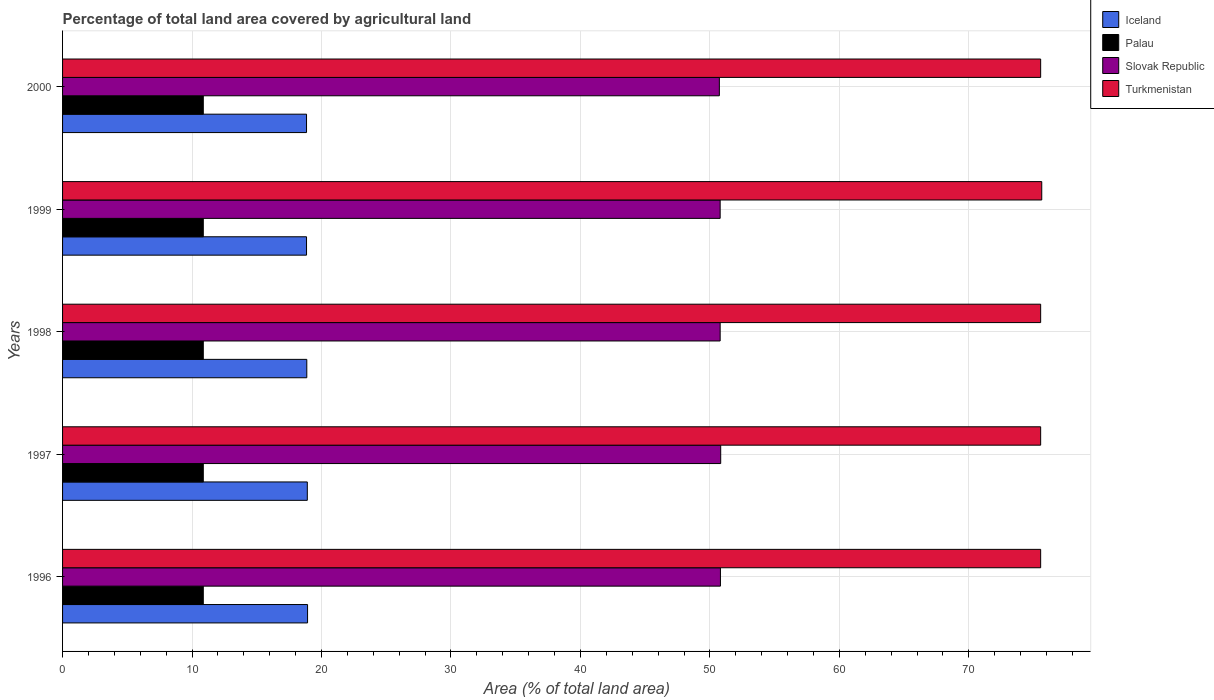How many different coloured bars are there?
Keep it short and to the point. 4. Are the number of bars per tick equal to the number of legend labels?
Your response must be concise. Yes. How many bars are there on the 1st tick from the top?
Provide a short and direct response. 4. What is the label of the 4th group of bars from the top?
Keep it short and to the point. 1997. What is the percentage of agricultural land in Iceland in 1999?
Offer a terse response. 18.84. Across all years, what is the maximum percentage of agricultural land in Turkmenistan?
Offer a terse response. 75.63. Across all years, what is the minimum percentage of agricultural land in Iceland?
Provide a succinct answer. 18.84. In which year was the percentage of agricultural land in Slovak Republic maximum?
Your response must be concise. 1997. In which year was the percentage of agricultural land in Turkmenistan minimum?
Ensure brevity in your answer.  1996. What is the total percentage of agricultural land in Turkmenistan in the graph?
Your answer should be very brief. 377.8. What is the difference between the percentage of agricultural land in Iceland in 1997 and the percentage of agricultural land in Palau in 1999?
Your response must be concise. 8.03. What is the average percentage of agricultural land in Iceland per year?
Your answer should be very brief. 18.87. In the year 1997, what is the difference between the percentage of agricultural land in Slovak Republic and percentage of agricultural land in Turkmenistan?
Your answer should be very brief. -24.71. What is the ratio of the percentage of agricultural land in Palau in 1996 to that in 1999?
Your answer should be very brief. 1. Is the percentage of agricultural land in Iceland in 1997 less than that in 1998?
Your answer should be very brief. No. What is the difference between the highest and the second highest percentage of agricultural land in Palau?
Your response must be concise. 0. What is the difference between the highest and the lowest percentage of agricultural land in Palau?
Your response must be concise. 0. Is the sum of the percentage of agricultural land in Iceland in 1996 and 1999 greater than the maximum percentage of agricultural land in Slovak Republic across all years?
Offer a terse response. No. Is it the case that in every year, the sum of the percentage of agricultural land in Slovak Republic and percentage of agricultural land in Palau is greater than the sum of percentage of agricultural land in Turkmenistan and percentage of agricultural land in Iceland?
Make the answer very short. No. What does the 3rd bar from the top in 1998 represents?
Your response must be concise. Palau. What does the 3rd bar from the bottom in 1996 represents?
Provide a short and direct response. Slovak Republic. Is it the case that in every year, the sum of the percentage of agricultural land in Iceland and percentage of agricultural land in Slovak Republic is greater than the percentage of agricultural land in Palau?
Your answer should be compact. Yes. How many bars are there?
Make the answer very short. 20. How many years are there in the graph?
Offer a terse response. 5. Does the graph contain any zero values?
Provide a succinct answer. No. Where does the legend appear in the graph?
Offer a terse response. Top right. How many legend labels are there?
Your answer should be very brief. 4. How are the legend labels stacked?
Provide a succinct answer. Vertical. What is the title of the graph?
Keep it short and to the point. Percentage of total land area covered by agricultural land. What is the label or title of the X-axis?
Offer a very short reply. Area (% of total land area). What is the label or title of the Y-axis?
Keep it short and to the point. Years. What is the Area (% of total land area) of Iceland in 1996?
Ensure brevity in your answer.  18.92. What is the Area (% of total land area) in Palau in 1996?
Make the answer very short. 10.87. What is the Area (% of total land area) in Slovak Republic in 1996?
Your answer should be compact. 50.81. What is the Area (% of total land area) of Turkmenistan in 1996?
Make the answer very short. 75.54. What is the Area (% of total land area) of Iceland in 1997?
Offer a very short reply. 18.9. What is the Area (% of total land area) of Palau in 1997?
Give a very brief answer. 10.87. What is the Area (% of total land area) in Slovak Republic in 1997?
Provide a short and direct response. 50.83. What is the Area (% of total land area) of Turkmenistan in 1997?
Provide a succinct answer. 75.54. What is the Area (% of total land area) in Iceland in 1998?
Keep it short and to the point. 18.86. What is the Area (% of total land area) in Palau in 1998?
Provide a short and direct response. 10.87. What is the Area (% of total land area) of Slovak Republic in 1998?
Make the answer very short. 50.79. What is the Area (% of total land area) of Turkmenistan in 1998?
Make the answer very short. 75.54. What is the Area (% of total land area) in Iceland in 1999?
Offer a very short reply. 18.84. What is the Area (% of total land area) of Palau in 1999?
Your answer should be compact. 10.87. What is the Area (% of total land area) of Slovak Republic in 1999?
Your answer should be compact. 50.79. What is the Area (% of total land area) in Turkmenistan in 1999?
Make the answer very short. 75.63. What is the Area (% of total land area) in Iceland in 2000?
Offer a very short reply. 18.84. What is the Area (% of total land area) of Palau in 2000?
Provide a succinct answer. 10.87. What is the Area (% of total land area) in Slovak Republic in 2000?
Provide a succinct answer. 50.73. What is the Area (% of total land area) in Turkmenistan in 2000?
Your response must be concise. 75.54. Across all years, what is the maximum Area (% of total land area) in Iceland?
Ensure brevity in your answer.  18.92. Across all years, what is the maximum Area (% of total land area) of Palau?
Your answer should be compact. 10.87. Across all years, what is the maximum Area (% of total land area) in Slovak Republic?
Ensure brevity in your answer.  50.83. Across all years, what is the maximum Area (% of total land area) in Turkmenistan?
Your response must be concise. 75.63. Across all years, what is the minimum Area (% of total land area) in Iceland?
Provide a succinct answer. 18.84. Across all years, what is the minimum Area (% of total land area) of Palau?
Ensure brevity in your answer.  10.87. Across all years, what is the minimum Area (% of total land area) of Slovak Republic?
Keep it short and to the point. 50.73. Across all years, what is the minimum Area (% of total land area) in Turkmenistan?
Make the answer very short. 75.54. What is the total Area (% of total land area) in Iceland in the graph?
Keep it short and to the point. 94.37. What is the total Area (% of total land area) of Palau in the graph?
Your response must be concise. 54.35. What is the total Area (% of total land area) in Slovak Republic in the graph?
Ensure brevity in your answer.  253.95. What is the total Area (% of total land area) of Turkmenistan in the graph?
Offer a very short reply. 377.8. What is the difference between the Area (% of total land area) of Slovak Republic in 1996 and that in 1997?
Offer a very short reply. -0.02. What is the difference between the Area (% of total land area) in Iceland in 1996 and that in 1998?
Give a very brief answer. 0.06. What is the difference between the Area (% of total land area) of Slovak Republic in 1996 and that in 1998?
Offer a very short reply. 0.02. What is the difference between the Area (% of total land area) of Turkmenistan in 1996 and that in 1998?
Offer a terse response. 0. What is the difference between the Area (% of total land area) in Iceland in 1996 and that in 1999?
Offer a terse response. 0.08. What is the difference between the Area (% of total land area) of Palau in 1996 and that in 1999?
Provide a succinct answer. 0. What is the difference between the Area (% of total land area) of Slovak Republic in 1996 and that in 1999?
Ensure brevity in your answer.  0.02. What is the difference between the Area (% of total land area) in Turkmenistan in 1996 and that in 1999?
Make the answer very short. -0.09. What is the difference between the Area (% of total land area) of Iceland in 1996 and that in 2000?
Give a very brief answer. 0.08. What is the difference between the Area (% of total land area) of Palau in 1996 and that in 2000?
Your answer should be compact. 0. What is the difference between the Area (% of total land area) in Slovak Republic in 1996 and that in 2000?
Provide a short and direct response. 0.08. What is the difference between the Area (% of total land area) of Iceland in 1997 and that in 1998?
Your response must be concise. 0.04. What is the difference between the Area (% of total land area) in Slovak Republic in 1997 and that in 1998?
Your answer should be compact. 0.04. What is the difference between the Area (% of total land area) of Iceland in 1997 and that in 1999?
Ensure brevity in your answer.  0.06. What is the difference between the Area (% of total land area) in Palau in 1997 and that in 1999?
Offer a very short reply. 0. What is the difference between the Area (% of total land area) in Slovak Republic in 1997 and that in 1999?
Give a very brief answer. 0.04. What is the difference between the Area (% of total land area) of Turkmenistan in 1997 and that in 1999?
Offer a very short reply. -0.09. What is the difference between the Area (% of total land area) of Iceland in 1997 and that in 2000?
Your answer should be compact. 0.06. What is the difference between the Area (% of total land area) in Slovak Republic in 1997 and that in 2000?
Offer a very short reply. 0.1. What is the difference between the Area (% of total land area) of Turkmenistan in 1997 and that in 2000?
Ensure brevity in your answer.  0. What is the difference between the Area (% of total land area) in Palau in 1998 and that in 1999?
Offer a very short reply. 0. What is the difference between the Area (% of total land area) in Turkmenistan in 1998 and that in 1999?
Provide a short and direct response. -0.09. What is the difference between the Area (% of total land area) in Iceland in 1998 and that in 2000?
Provide a succinct answer. 0.02. What is the difference between the Area (% of total land area) in Palau in 1998 and that in 2000?
Give a very brief answer. 0. What is the difference between the Area (% of total land area) of Slovak Republic in 1998 and that in 2000?
Offer a terse response. 0.06. What is the difference between the Area (% of total land area) in Slovak Republic in 1999 and that in 2000?
Your answer should be compact. 0.06. What is the difference between the Area (% of total land area) of Turkmenistan in 1999 and that in 2000?
Make the answer very short. 0.09. What is the difference between the Area (% of total land area) in Iceland in 1996 and the Area (% of total land area) in Palau in 1997?
Ensure brevity in your answer.  8.05. What is the difference between the Area (% of total land area) in Iceland in 1996 and the Area (% of total land area) in Slovak Republic in 1997?
Ensure brevity in your answer.  -31.91. What is the difference between the Area (% of total land area) in Iceland in 1996 and the Area (% of total land area) in Turkmenistan in 1997?
Make the answer very short. -56.62. What is the difference between the Area (% of total land area) of Palau in 1996 and the Area (% of total land area) of Slovak Republic in 1997?
Give a very brief answer. -39.96. What is the difference between the Area (% of total land area) in Palau in 1996 and the Area (% of total land area) in Turkmenistan in 1997?
Ensure brevity in your answer.  -64.67. What is the difference between the Area (% of total land area) of Slovak Republic in 1996 and the Area (% of total land area) of Turkmenistan in 1997?
Ensure brevity in your answer.  -24.73. What is the difference between the Area (% of total land area) in Iceland in 1996 and the Area (% of total land area) in Palau in 1998?
Give a very brief answer. 8.05. What is the difference between the Area (% of total land area) in Iceland in 1996 and the Area (% of total land area) in Slovak Republic in 1998?
Make the answer very short. -31.87. What is the difference between the Area (% of total land area) in Iceland in 1996 and the Area (% of total land area) in Turkmenistan in 1998?
Your response must be concise. -56.62. What is the difference between the Area (% of total land area) in Palau in 1996 and the Area (% of total land area) in Slovak Republic in 1998?
Your answer should be compact. -39.92. What is the difference between the Area (% of total land area) of Palau in 1996 and the Area (% of total land area) of Turkmenistan in 1998?
Give a very brief answer. -64.67. What is the difference between the Area (% of total land area) in Slovak Republic in 1996 and the Area (% of total land area) in Turkmenistan in 1998?
Offer a terse response. -24.73. What is the difference between the Area (% of total land area) of Iceland in 1996 and the Area (% of total land area) of Palau in 1999?
Provide a short and direct response. 8.05. What is the difference between the Area (% of total land area) in Iceland in 1996 and the Area (% of total land area) in Slovak Republic in 1999?
Offer a very short reply. -31.87. What is the difference between the Area (% of total land area) in Iceland in 1996 and the Area (% of total land area) in Turkmenistan in 1999?
Make the answer very short. -56.71. What is the difference between the Area (% of total land area) of Palau in 1996 and the Area (% of total land area) of Slovak Republic in 1999?
Your answer should be very brief. -39.92. What is the difference between the Area (% of total land area) in Palau in 1996 and the Area (% of total land area) in Turkmenistan in 1999?
Give a very brief answer. -64.76. What is the difference between the Area (% of total land area) of Slovak Republic in 1996 and the Area (% of total land area) of Turkmenistan in 1999?
Offer a terse response. -24.82. What is the difference between the Area (% of total land area) of Iceland in 1996 and the Area (% of total land area) of Palau in 2000?
Your answer should be very brief. 8.05. What is the difference between the Area (% of total land area) in Iceland in 1996 and the Area (% of total land area) in Slovak Republic in 2000?
Provide a short and direct response. -31.8. What is the difference between the Area (% of total land area) in Iceland in 1996 and the Area (% of total land area) in Turkmenistan in 2000?
Keep it short and to the point. -56.62. What is the difference between the Area (% of total land area) of Palau in 1996 and the Area (% of total land area) of Slovak Republic in 2000?
Offer a terse response. -39.86. What is the difference between the Area (% of total land area) of Palau in 1996 and the Area (% of total land area) of Turkmenistan in 2000?
Make the answer very short. -64.67. What is the difference between the Area (% of total land area) in Slovak Republic in 1996 and the Area (% of total land area) in Turkmenistan in 2000?
Keep it short and to the point. -24.73. What is the difference between the Area (% of total land area) in Iceland in 1997 and the Area (% of total land area) in Palau in 1998?
Provide a short and direct response. 8.03. What is the difference between the Area (% of total land area) of Iceland in 1997 and the Area (% of total land area) of Slovak Republic in 1998?
Make the answer very short. -31.89. What is the difference between the Area (% of total land area) in Iceland in 1997 and the Area (% of total land area) in Turkmenistan in 1998?
Your answer should be very brief. -56.64. What is the difference between the Area (% of total land area) in Palau in 1997 and the Area (% of total land area) in Slovak Republic in 1998?
Keep it short and to the point. -39.92. What is the difference between the Area (% of total land area) of Palau in 1997 and the Area (% of total land area) of Turkmenistan in 1998?
Offer a very short reply. -64.67. What is the difference between the Area (% of total land area) in Slovak Republic in 1997 and the Area (% of total land area) in Turkmenistan in 1998?
Offer a very short reply. -24.71. What is the difference between the Area (% of total land area) in Iceland in 1997 and the Area (% of total land area) in Palau in 1999?
Offer a very short reply. 8.03. What is the difference between the Area (% of total land area) of Iceland in 1997 and the Area (% of total land area) of Slovak Republic in 1999?
Provide a short and direct response. -31.89. What is the difference between the Area (% of total land area) of Iceland in 1997 and the Area (% of total land area) of Turkmenistan in 1999?
Your answer should be very brief. -56.73. What is the difference between the Area (% of total land area) in Palau in 1997 and the Area (% of total land area) in Slovak Republic in 1999?
Your answer should be compact. -39.92. What is the difference between the Area (% of total land area) of Palau in 1997 and the Area (% of total land area) of Turkmenistan in 1999?
Offer a very short reply. -64.76. What is the difference between the Area (% of total land area) of Slovak Republic in 1997 and the Area (% of total land area) of Turkmenistan in 1999?
Provide a succinct answer. -24.8. What is the difference between the Area (% of total land area) of Iceland in 1997 and the Area (% of total land area) of Palau in 2000?
Give a very brief answer. 8.03. What is the difference between the Area (% of total land area) of Iceland in 1997 and the Area (% of total land area) of Slovak Republic in 2000?
Your answer should be compact. -31.82. What is the difference between the Area (% of total land area) in Iceland in 1997 and the Area (% of total land area) in Turkmenistan in 2000?
Keep it short and to the point. -56.64. What is the difference between the Area (% of total land area) of Palau in 1997 and the Area (% of total land area) of Slovak Republic in 2000?
Ensure brevity in your answer.  -39.86. What is the difference between the Area (% of total land area) of Palau in 1997 and the Area (% of total land area) of Turkmenistan in 2000?
Give a very brief answer. -64.67. What is the difference between the Area (% of total land area) in Slovak Republic in 1997 and the Area (% of total land area) in Turkmenistan in 2000?
Provide a succinct answer. -24.71. What is the difference between the Area (% of total land area) of Iceland in 1998 and the Area (% of total land area) of Palau in 1999?
Your answer should be compact. 7.99. What is the difference between the Area (% of total land area) of Iceland in 1998 and the Area (% of total land area) of Slovak Republic in 1999?
Offer a terse response. -31.93. What is the difference between the Area (% of total land area) in Iceland in 1998 and the Area (% of total land area) in Turkmenistan in 1999?
Offer a very short reply. -56.77. What is the difference between the Area (% of total land area) of Palau in 1998 and the Area (% of total land area) of Slovak Republic in 1999?
Offer a very short reply. -39.92. What is the difference between the Area (% of total land area) of Palau in 1998 and the Area (% of total land area) of Turkmenistan in 1999?
Your answer should be very brief. -64.76. What is the difference between the Area (% of total land area) in Slovak Republic in 1998 and the Area (% of total land area) in Turkmenistan in 1999?
Make the answer very short. -24.84. What is the difference between the Area (% of total land area) in Iceland in 1998 and the Area (% of total land area) in Palau in 2000?
Provide a succinct answer. 7.99. What is the difference between the Area (% of total land area) of Iceland in 1998 and the Area (% of total land area) of Slovak Republic in 2000?
Give a very brief answer. -31.86. What is the difference between the Area (% of total land area) in Iceland in 1998 and the Area (% of total land area) in Turkmenistan in 2000?
Your answer should be compact. -56.68. What is the difference between the Area (% of total land area) in Palau in 1998 and the Area (% of total land area) in Slovak Republic in 2000?
Make the answer very short. -39.86. What is the difference between the Area (% of total land area) of Palau in 1998 and the Area (% of total land area) of Turkmenistan in 2000?
Give a very brief answer. -64.67. What is the difference between the Area (% of total land area) in Slovak Republic in 1998 and the Area (% of total land area) in Turkmenistan in 2000?
Your answer should be very brief. -24.75. What is the difference between the Area (% of total land area) of Iceland in 1999 and the Area (% of total land area) of Palau in 2000?
Provide a short and direct response. 7.97. What is the difference between the Area (% of total land area) in Iceland in 1999 and the Area (% of total land area) in Slovak Republic in 2000?
Your response must be concise. -31.88. What is the difference between the Area (% of total land area) in Iceland in 1999 and the Area (% of total land area) in Turkmenistan in 2000?
Keep it short and to the point. -56.7. What is the difference between the Area (% of total land area) in Palau in 1999 and the Area (% of total land area) in Slovak Republic in 2000?
Offer a terse response. -39.86. What is the difference between the Area (% of total land area) of Palau in 1999 and the Area (% of total land area) of Turkmenistan in 2000?
Your response must be concise. -64.67. What is the difference between the Area (% of total land area) of Slovak Republic in 1999 and the Area (% of total land area) of Turkmenistan in 2000?
Your answer should be compact. -24.75. What is the average Area (% of total land area) of Iceland per year?
Your answer should be very brief. 18.87. What is the average Area (% of total land area) in Palau per year?
Offer a very short reply. 10.87. What is the average Area (% of total land area) in Slovak Republic per year?
Provide a short and direct response. 50.79. What is the average Area (% of total land area) of Turkmenistan per year?
Make the answer very short. 75.56. In the year 1996, what is the difference between the Area (% of total land area) in Iceland and Area (% of total land area) in Palau?
Your answer should be compact. 8.05. In the year 1996, what is the difference between the Area (% of total land area) of Iceland and Area (% of total land area) of Slovak Republic?
Give a very brief answer. -31.89. In the year 1996, what is the difference between the Area (% of total land area) in Iceland and Area (% of total land area) in Turkmenistan?
Offer a very short reply. -56.62. In the year 1996, what is the difference between the Area (% of total land area) of Palau and Area (% of total land area) of Slovak Republic?
Provide a short and direct response. -39.94. In the year 1996, what is the difference between the Area (% of total land area) of Palau and Area (% of total land area) of Turkmenistan?
Your response must be concise. -64.67. In the year 1996, what is the difference between the Area (% of total land area) of Slovak Republic and Area (% of total land area) of Turkmenistan?
Provide a short and direct response. -24.73. In the year 1997, what is the difference between the Area (% of total land area) of Iceland and Area (% of total land area) of Palau?
Offer a terse response. 8.03. In the year 1997, what is the difference between the Area (% of total land area) of Iceland and Area (% of total land area) of Slovak Republic?
Your answer should be very brief. -31.93. In the year 1997, what is the difference between the Area (% of total land area) in Iceland and Area (% of total land area) in Turkmenistan?
Your answer should be very brief. -56.64. In the year 1997, what is the difference between the Area (% of total land area) in Palau and Area (% of total land area) in Slovak Republic?
Give a very brief answer. -39.96. In the year 1997, what is the difference between the Area (% of total land area) of Palau and Area (% of total land area) of Turkmenistan?
Your answer should be very brief. -64.67. In the year 1997, what is the difference between the Area (% of total land area) in Slovak Republic and Area (% of total land area) in Turkmenistan?
Make the answer very short. -24.71. In the year 1998, what is the difference between the Area (% of total land area) in Iceland and Area (% of total land area) in Palau?
Offer a terse response. 7.99. In the year 1998, what is the difference between the Area (% of total land area) in Iceland and Area (% of total land area) in Slovak Republic?
Ensure brevity in your answer.  -31.93. In the year 1998, what is the difference between the Area (% of total land area) of Iceland and Area (% of total land area) of Turkmenistan?
Give a very brief answer. -56.68. In the year 1998, what is the difference between the Area (% of total land area) of Palau and Area (% of total land area) of Slovak Republic?
Ensure brevity in your answer.  -39.92. In the year 1998, what is the difference between the Area (% of total land area) in Palau and Area (% of total land area) in Turkmenistan?
Your answer should be compact. -64.67. In the year 1998, what is the difference between the Area (% of total land area) of Slovak Republic and Area (% of total land area) of Turkmenistan?
Your answer should be compact. -24.75. In the year 1999, what is the difference between the Area (% of total land area) of Iceland and Area (% of total land area) of Palau?
Your response must be concise. 7.97. In the year 1999, what is the difference between the Area (% of total land area) of Iceland and Area (% of total land area) of Slovak Republic?
Ensure brevity in your answer.  -31.95. In the year 1999, what is the difference between the Area (% of total land area) in Iceland and Area (% of total land area) in Turkmenistan?
Provide a succinct answer. -56.79. In the year 1999, what is the difference between the Area (% of total land area) of Palau and Area (% of total land area) of Slovak Republic?
Your answer should be compact. -39.92. In the year 1999, what is the difference between the Area (% of total land area) in Palau and Area (% of total land area) in Turkmenistan?
Offer a very short reply. -64.76. In the year 1999, what is the difference between the Area (% of total land area) in Slovak Republic and Area (% of total land area) in Turkmenistan?
Keep it short and to the point. -24.84. In the year 2000, what is the difference between the Area (% of total land area) of Iceland and Area (% of total land area) of Palau?
Keep it short and to the point. 7.97. In the year 2000, what is the difference between the Area (% of total land area) in Iceland and Area (% of total land area) in Slovak Republic?
Give a very brief answer. -31.88. In the year 2000, what is the difference between the Area (% of total land area) of Iceland and Area (% of total land area) of Turkmenistan?
Offer a very short reply. -56.7. In the year 2000, what is the difference between the Area (% of total land area) in Palau and Area (% of total land area) in Slovak Republic?
Your response must be concise. -39.86. In the year 2000, what is the difference between the Area (% of total land area) of Palau and Area (% of total land area) of Turkmenistan?
Offer a very short reply. -64.67. In the year 2000, what is the difference between the Area (% of total land area) in Slovak Republic and Area (% of total land area) in Turkmenistan?
Offer a very short reply. -24.82. What is the ratio of the Area (% of total land area) of Palau in 1996 to that in 1997?
Keep it short and to the point. 1. What is the ratio of the Area (% of total land area) of Turkmenistan in 1996 to that in 1997?
Your answer should be very brief. 1. What is the ratio of the Area (% of total land area) in Palau in 1996 to that in 1998?
Keep it short and to the point. 1. What is the ratio of the Area (% of total land area) in Iceland in 1996 to that in 1999?
Ensure brevity in your answer.  1. What is the ratio of the Area (% of total land area) of Slovak Republic in 1996 to that in 1999?
Provide a short and direct response. 1. What is the ratio of the Area (% of total land area) in Palau in 1996 to that in 2000?
Your answer should be compact. 1. What is the ratio of the Area (% of total land area) in Turkmenistan in 1996 to that in 2000?
Make the answer very short. 1. What is the ratio of the Area (% of total land area) in Iceland in 1997 to that in 1998?
Your answer should be very brief. 1. What is the ratio of the Area (% of total land area) in Palau in 1997 to that in 1998?
Keep it short and to the point. 1. What is the ratio of the Area (% of total land area) of Slovak Republic in 1997 to that in 1998?
Provide a succinct answer. 1. What is the ratio of the Area (% of total land area) in Iceland in 1997 to that in 1999?
Offer a terse response. 1. What is the ratio of the Area (% of total land area) of Palau in 1997 to that in 1999?
Provide a short and direct response. 1. What is the ratio of the Area (% of total land area) in Slovak Republic in 1997 to that in 1999?
Offer a terse response. 1. What is the ratio of the Area (% of total land area) in Turkmenistan in 1997 to that in 1999?
Provide a succinct answer. 1. What is the ratio of the Area (% of total land area) of Iceland in 1997 to that in 2000?
Your answer should be very brief. 1. What is the ratio of the Area (% of total land area) of Palau in 1997 to that in 2000?
Offer a very short reply. 1. What is the ratio of the Area (% of total land area) of Slovak Republic in 1997 to that in 2000?
Ensure brevity in your answer.  1. What is the ratio of the Area (% of total land area) of Iceland in 1998 to that in 1999?
Give a very brief answer. 1. What is the ratio of the Area (% of total land area) in Slovak Republic in 1998 to that in 1999?
Your answer should be very brief. 1. What is the ratio of the Area (% of total land area) of Iceland in 1998 to that in 2000?
Provide a short and direct response. 1. What is the ratio of the Area (% of total land area) of Palau in 1998 to that in 2000?
Provide a short and direct response. 1. What is the ratio of the Area (% of total land area) of Turkmenistan in 1998 to that in 2000?
Make the answer very short. 1. What is the ratio of the Area (% of total land area) in Iceland in 1999 to that in 2000?
Your response must be concise. 1. What is the ratio of the Area (% of total land area) in Palau in 1999 to that in 2000?
Give a very brief answer. 1. What is the ratio of the Area (% of total land area) of Slovak Republic in 1999 to that in 2000?
Your answer should be compact. 1. What is the difference between the highest and the second highest Area (% of total land area) of Palau?
Provide a short and direct response. 0. What is the difference between the highest and the second highest Area (% of total land area) in Slovak Republic?
Provide a succinct answer. 0.02. What is the difference between the highest and the second highest Area (% of total land area) in Turkmenistan?
Keep it short and to the point. 0.09. What is the difference between the highest and the lowest Area (% of total land area) of Iceland?
Make the answer very short. 0.08. What is the difference between the highest and the lowest Area (% of total land area) in Palau?
Your response must be concise. 0. What is the difference between the highest and the lowest Area (% of total land area) in Slovak Republic?
Your answer should be compact. 0.1. What is the difference between the highest and the lowest Area (% of total land area) of Turkmenistan?
Offer a terse response. 0.09. 